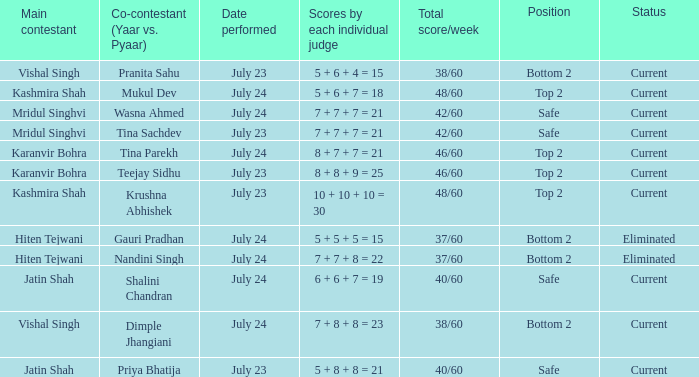Who is the main contestant with a total score/week of 42/60 and a co-contestant (Yaar vs. Pyaa) of Tina Sachdev? Mridul Singhvi. 